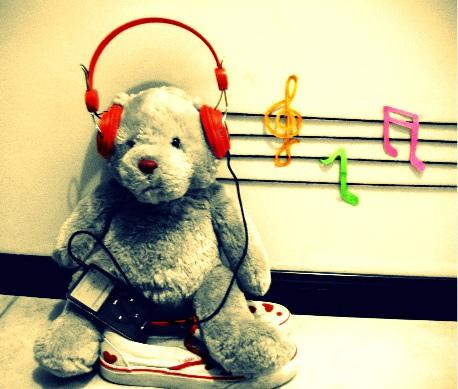Question: why are there music notes?
Choices:
A. Because the bear is listening to music.
B. Because a radio is playing.
C. Because a bird is singing.
D. Because a man is playing a flute.
Answer with the letter. Answer: A Question: who is wearing headphones?
Choices:
A. The man jogging.
B. The teenager in the hat.
C. The teddy bear.
D. The disc jockey m.
Answer with the letter. Answer: C Question: where are the music notes?
Choices:
A. On the wall.
B. On the blackboard.
C. On the sheet of music.
D. In the book.
Answer with the letter. Answer: A Question: what is the bear listening to?
Choices:
A. A radio.
B. An ipod.
C. A bird.
D. A ringing phone.
Answer with the letter. Answer: B Question: how many music notes are on the wall?
Choices:
A. 10.
B. 12.
C. 3.
D. 6.
Answer with the letter. Answer: C 